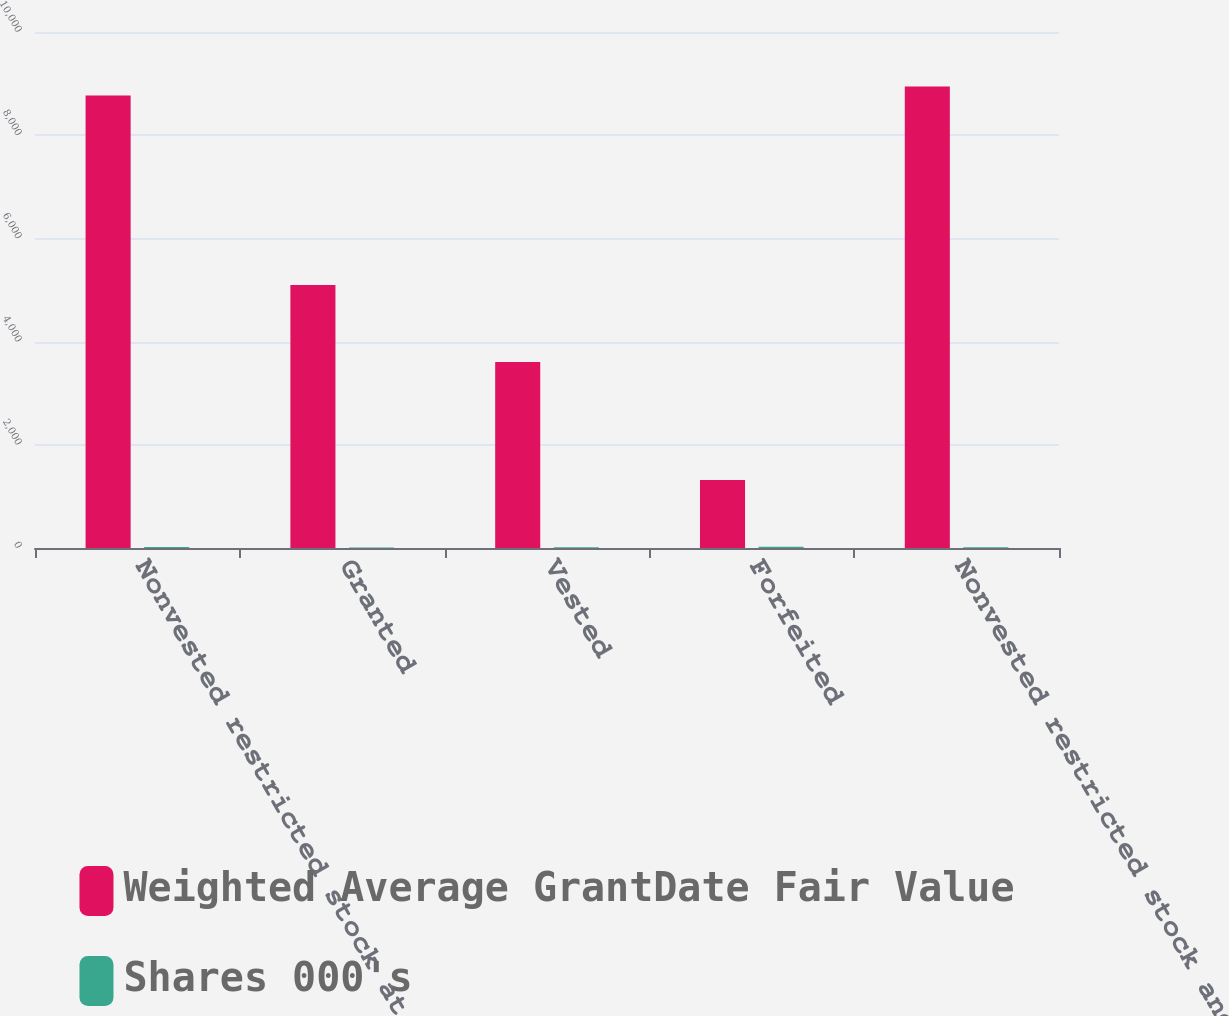<chart> <loc_0><loc_0><loc_500><loc_500><stacked_bar_chart><ecel><fcel>Nonvested restricted stock at<fcel>Granted<fcel>Vested<fcel>Forfeited<fcel>Nonvested restricted stock and<nl><fcel>Weighted Average GrantDate Fair Value<fcel>8770<fcel>5098<fcel>3607<fcel>1319<fcel>8942<nl><fcel>Shares 000's<fcel>18.8<fcel>10.89<fcel>13.59<fcel>24.83<fcel>15.51<nl></chart> 